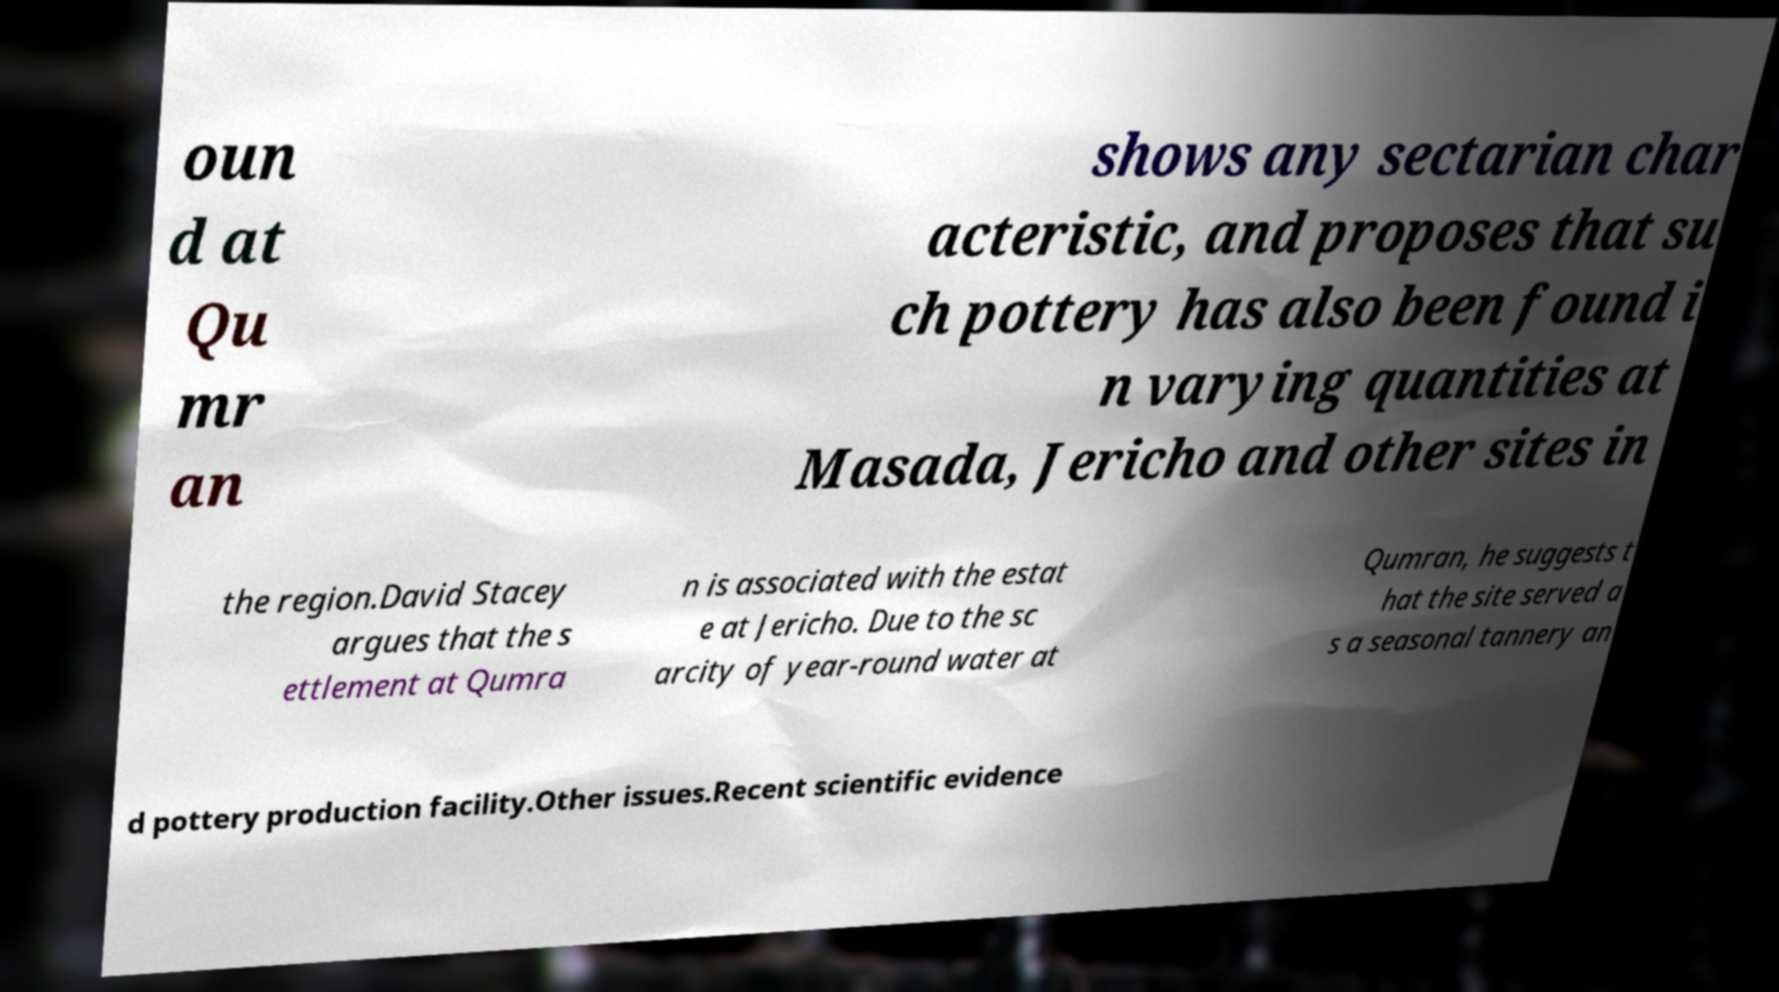I need the written content from this picture converted into text. Can you do that? oun d at Qu mr an shows any sectarian char acteristic, and proposes that su ch pottery has also been found i n varying quantities at Masada, Jericho and other sites in the region.David Stacey argues that the s ettlement at Qumra n is associated with the estat e at Jericho. Due to the sc arcity of year-round water at Qumran, he suggests t hat the site served a s a seasonal tannery an d pottery production facility.Other issues.Recent scientific evidence 